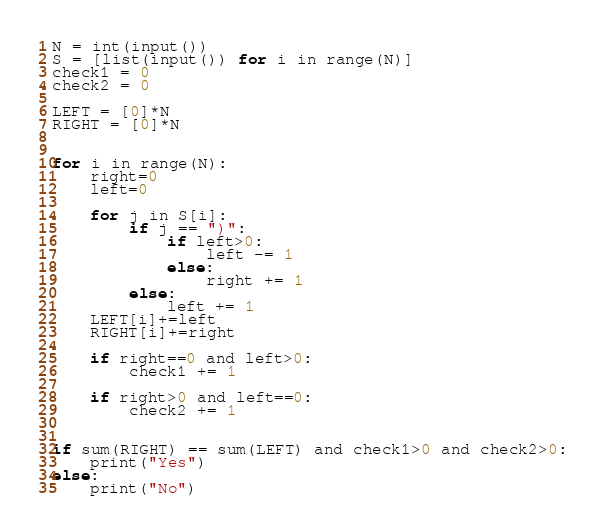Convert code to text. <code><loc_0><loc_0><loc_500><loc_500><_Python_>N = int(input())
S = [list(input()) for i in range(N)]
check1 = 0
check2 = 0

LEFT = [0]*N
RIGHT = [0]*N


for i in range(N):
    right=0
    left=0
    
    for j in S[i]:
        if j == ")":
            if left>0:
                left -= 1
            else:
                right += 1
        else:
            left += 1
    LEFT[i]+=left
    RIGHT[i]+=right
    
    if right==0 and left>0:
        check1 += 1

    if right>0 and left==0:
        check2 += 1

        
if sum(RIGHT) == sum(LEFT) and check1>0 and check2>0:
    print("Yes")
else:
    print("No")</code> 